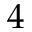Convert formula to latex. <formula><loc_0><loc_0><loc_500><loc_500>4</formula> 